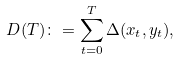<formula> <loc_0><loc_0><loc_500><loc_500>D ( T ) \colon = \sum _ { t = 0 } ^ { T } \Delta ( x _ { t } , y _ { t } ) ,</formula> 